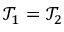Convert formula to latex. <formula><loc_0><loc_0><loc_500><loc_500>\mathcal { T } _ { 1 } = \mathcal { T } _ { 2 }</formula> 